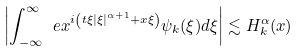<formula> <loc_0><loc_0><loc_500><loc_500>\left | \int _ { - \infty } ^ { \infty } \ e x ^ { i \left ( t \xi | \xi | ^ { \alpha + 1 } + x \xi \right ) } \psi _ { k } ( \xi ) d \xi \right | \lesssim H ^ { \alpha } _ { k } ( x )</formula> 